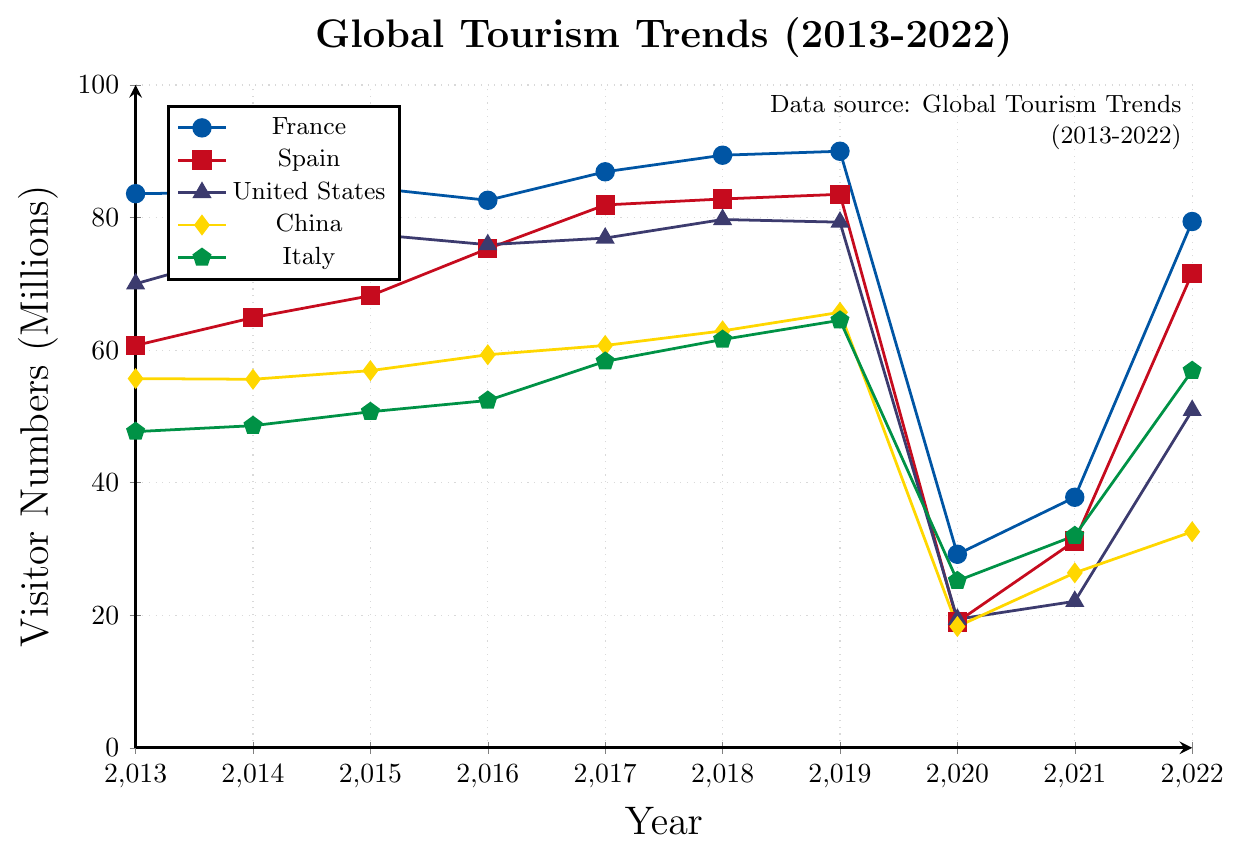what was the highest number of visitors that France received during the period? The plot shows the visitor numbers for France from 2013 to 2022 with the highest number in 2019, represented by a blue line.
Answer: 90.0 million Compare the lowest visitor numbers between Spain and the United States. Which country had fewer visitors? The plot shows the lowest visitor numbers for both countries in 2020. Spain had 19.0 million visitors, represented by a red line, and the United States had 19.4 million visitors, represented by a blue line.
Answer: Spain What is the average number of visitors for Italy from 2013 to 2022? Sum of visitor numbers for Italy (2013-2022) = 47.7 + 48.6 + 50.7 + 52.4 + 58.3 + 61.6 + 64.5 + 25.2 + 32.0 + 56.9 = 498.9. The number of years = 10. So, average = 498.9 / 10 = 49.89.
Answer: 49.89 million How did France's visitor numbers in 2020 compare to the previous year in 2019? France had 90.0 million visitors in 2019 and 29.2 million in 2020. So, the difference = 90.0 - 29.2 = 60.8 million fewer visitors in 2020 compared to 2019.
Answer: 60.8 million decrease Which country had the most significant drop in visitor numbers between 2019 and 2020? By visually comparing the height of the lines in 2019 and 2020, it seems that France had the most significant drop (from 90.0 to 29.2 million), a decrease of 60.8 million.
Answer: France How many countries had visitor numbers below 20 million in 2020? Looking at the plot for the year 2020, France (29.2), Spain (19.0), USA (19.4), China (18.3), Italy (25.2), Turkey (12.7), Mexico (24.3), Thailand (6.7), Germany (12.4), and UK (11.1). Spain, USA, China, Turkey, Thailand, Germany, and UK had visitor numbers below 20 million.
Answer: 7 countries Which year experienced the lowest overall visitor numbers for Thailand? By referring to the green line for Thailand over the years, the lowest point is in 2021, with only 0.4 million visitors.
Answer: 2021 What was the difference in visitor numbers between Spain and Germany in 2017? Spain had 81.9 million visitors in 2017 (red line) and Germany had 37.5 million visitors (green line). Difference = 81.9 - 37.5 = 44.4 million.
Answer: 44.4 million How many countries had a visitor number decrease from 2019 to 2020? All countries show a decrease in the height of the lines from 2019 to 2020. The countries are: France, Spain, USA, China, Italy, Turkey, Mexico, Thailand, Germany, and UK.
Answer: 10 countries Which country had the highest number of visitors in 2022? Refer to the end points of all the lines in 2022, the line representing France reached the highest with 79.4 million visitors.
Answer: France 